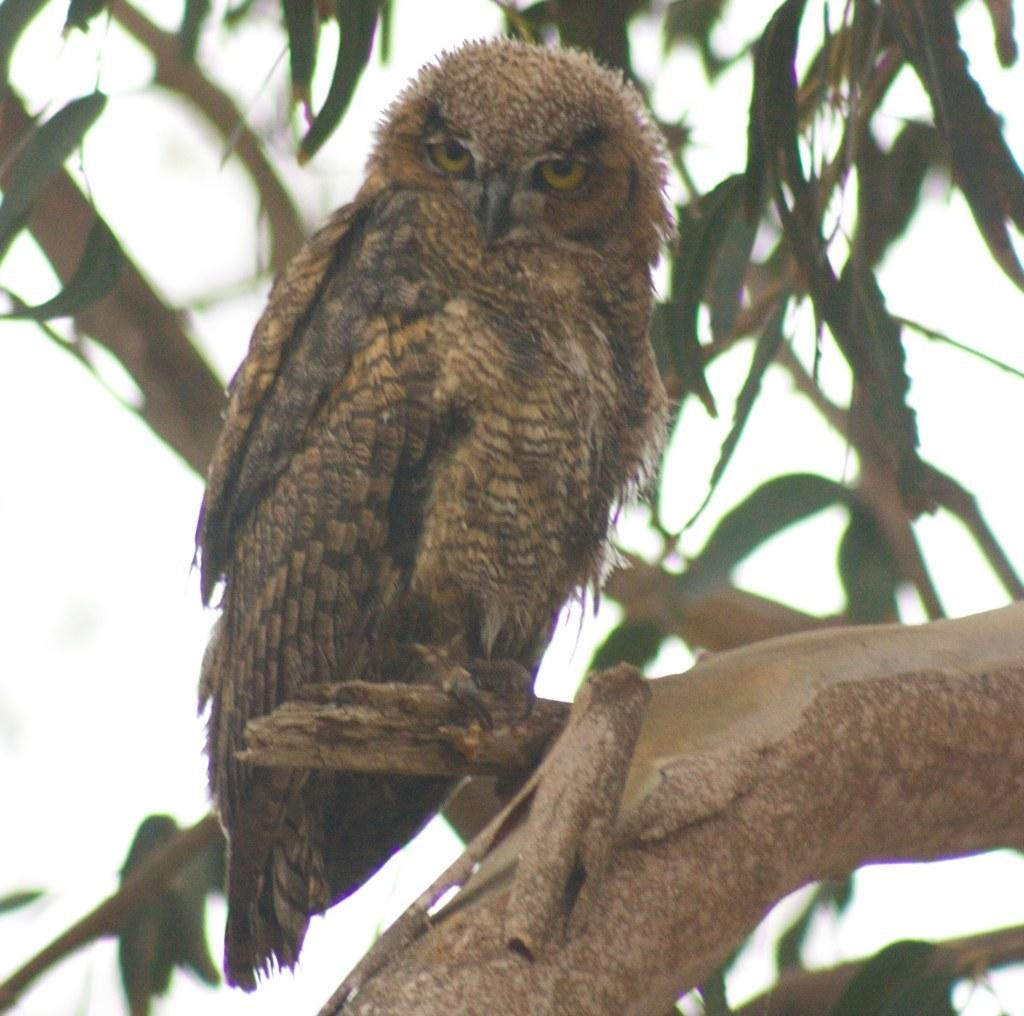What animal is in the image? There is an owl in the image. What is the owl standing on? The owl is standing on a branch. What is the branch a part of? The branch is part of a tree. What can be seen in the background of the image? There are branches with leaves in the background of the image. What type of mint is growing on the owl's head in the image? There is no mint growing on the owl's head in the image; it is a tree branch. 